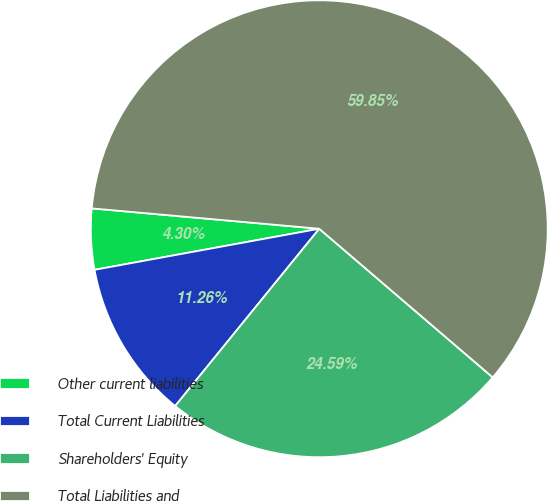Convert chart. <chart><loc_0><loc_0><loc_500><loc_500><pie_chart><fcel>Other current liabilities<fcel>Total Current Liabilities<fcel>Shareholders' Equity<fcel>Total Liabilities and<nl><fcel>4.3%<fcel>11.26%<fcel>24.59%<fcel>59.86%<nl></chart> 